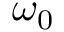<formula> <loc_0><loc_0><loc_500><loc_500>\omega _ { 0 }</formula> 